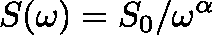Convert formula to latex. <formula><loc_0><loc_0><loc_500><loc_500>S ( \omega ) = S _ { 0 } / \omega ^ { \alpha }</formula> 